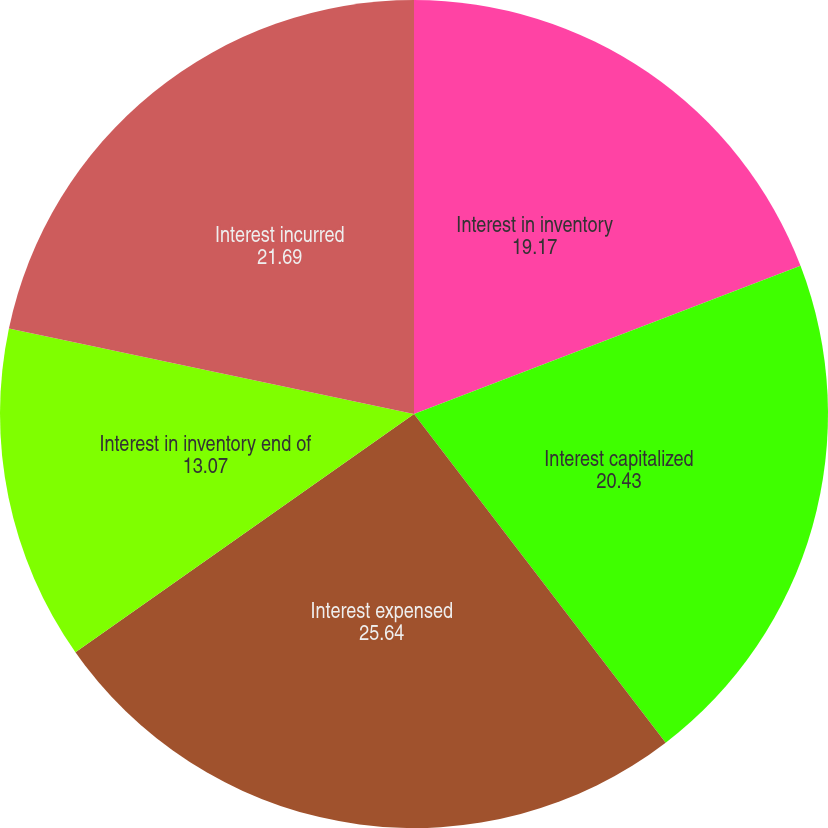Convert chart. <chart><loc_0><loc_0><loc_500><loc_500><pie_chart><fcel>Interest in inventory<fcel>Interest capitalized<fcel>Interest expensed<fcel>Interest in inventory end of<fcel>Interest incurred<nl><fcel>19.17%<fcel>20.43%<fcel>25.64%<fcel>13.07%<fcel>21.69%<nl></chart> 